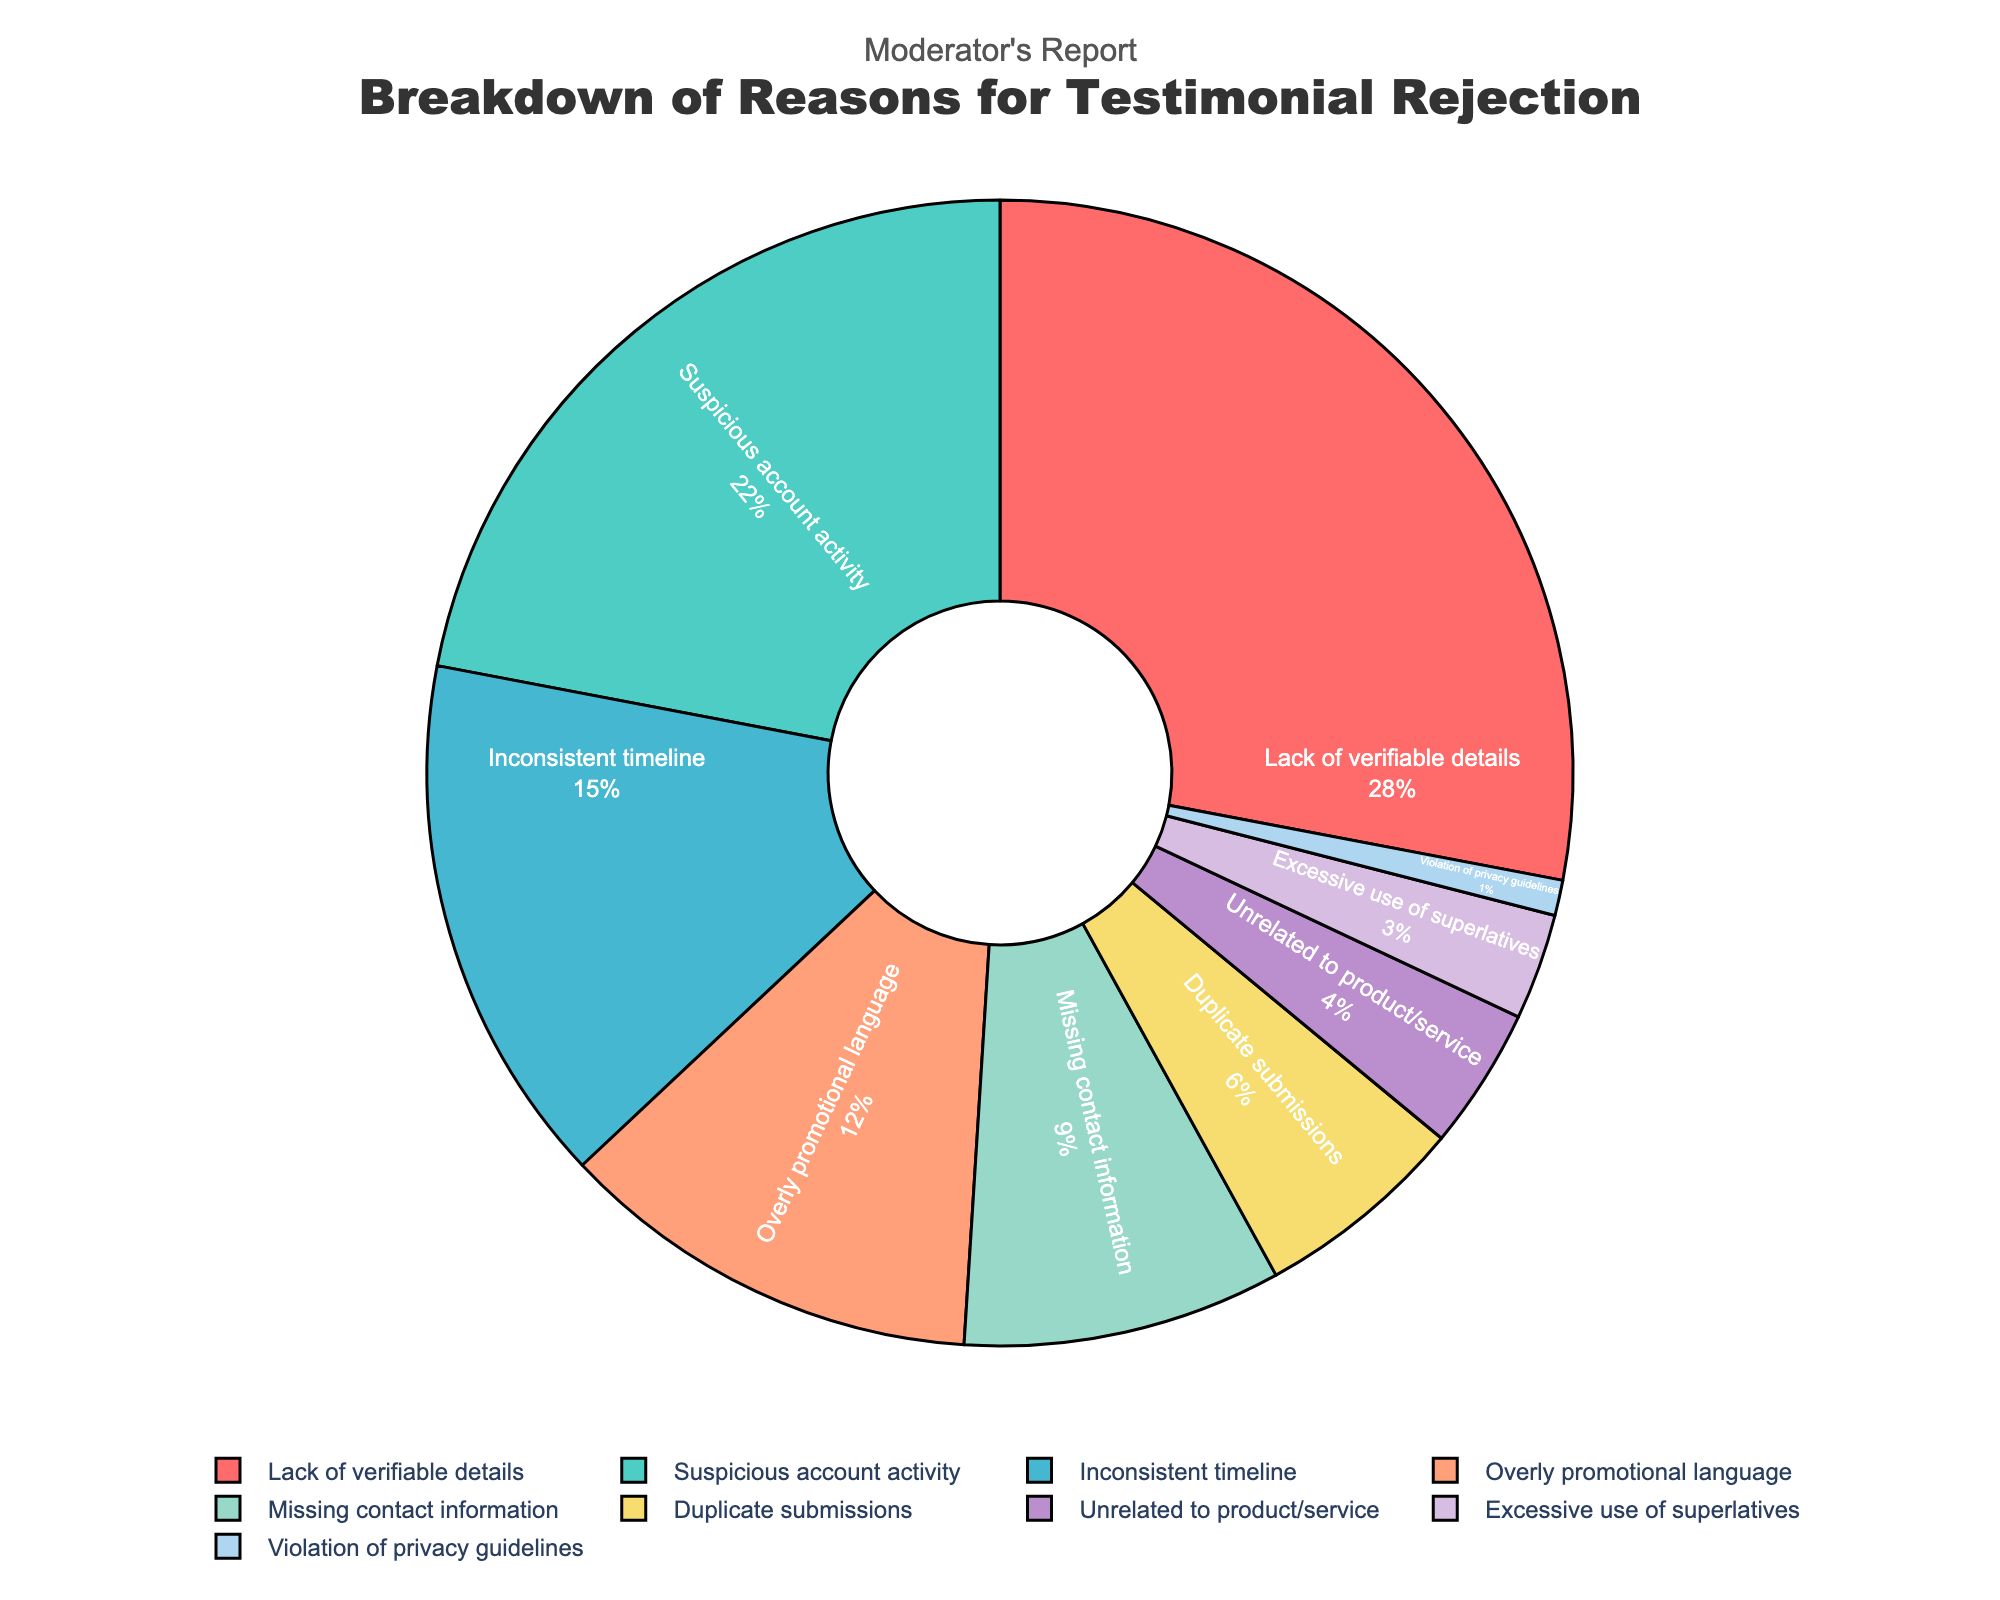What is the most common reason for testimonial rejection? The most common reason can be identified by looking for the segment with the largest percentage in the pie chart. "Lack of verifiable details" is the largest segment at 28%.
Answer: Lack of verifiable details Which reason accounts for the second-highest percentage of testimonial rejections? The second-largest segment in the pie chart, following the largest segment, is "Suspicious account activity" at 22%.
Answer: Suspicious account activity What is the combined percentage of rejections due to "Overly promotional language" and "Missing contact information"? Add the percentages of "Overly promotional language" (12%) and "Missing contact information" (9%). 12% + 9% = 21%.
Answer: 21% Is the percentage for "Duplicate submissions" higher or lower than "Unrelated to product/service"? "Duplicate submissions" accounts for 6% while "Unrelated to product/service" accounts for 4%, so "Duplicate submissions" is higher.
Answer: Higher What is the total percentage for reasons related to suspicious behaviors (such as "Suspicious account activity" and "Duplicate submissions")? Add the percentages of "Suspicious account activity" (22%) and "Duplicate submissions" (6%). 22% + 6% = 28%.
Answer: 28% How much larger is the percentage of "Lack of verifiable details" compared to "Excessive use of superlatives"? Subtract the percentage of "Excessive use of superlatives" (3%) from "Lack of verifiable details" (28%). 28% - 3% = 25%.
Answer: 25% Are there more reasons that account for 10% or more of the total rejections, or fewer than 10%? There are four reasons accounting for 10% or more ("Lack of verifiable details," "Suspicious account activity," "Inconsistent timeline," "Overly promotional language") and five under 10% ("Missing contact information," "Duplicate submissions," "Unrelated to product/service," "Excessive use of superlatives," "Violation of privacy guidelines"). So, more reasons are under 10%.
Answer: Fewer If you combine the percentages of "Violation of privacy guidelines" and "Unrelated to product/service," do they exceed "Inconsistent timeline"? Add the percentages of "Violation of privacy guidelines" (1%) and "Unrelated to product/service" (4%). 1% + 4% = 5%, which is less than "Inconsistent timeline" at 15%.
Answer: No Between the reasons "Missing contact information" and "Duplicate submissions," which one accounts for a larger portion of testimonial rejections? "Missing contact information" is 9%, while "Duplicate submissions" is 6%, so "Missing contact information" is larger.
Answer: Missing contact information What color represents the reason with the smallest percentage, and which reason is it? The reason with the smallest percentage (1%) is "Violation of privacy guidelines," represented by the color corresponding to that segment in the pie chart (violet).
Answer: Violet, Violation of privacy guidelines 